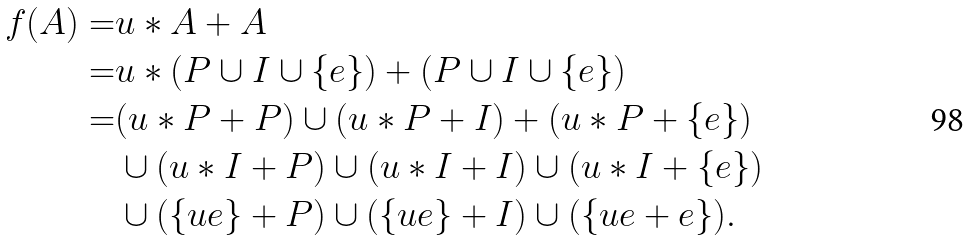Convert formula to latex. <formula><loc_0><loc_0><loc_500><loc_500>f ( A ) = & u \ast A + A \\ = & u \ast ( P \cup I \cup \{ e \} ) + ( P \cup I \cup \{ e \} ) \\ = & ( u \ast P + P ) \cup ( u \ast P + I ) + ( u \ast P + \{ e \} ) \\ & \cup ( u \ast I + P ) \cup ( u \ast I + I ) \cup ( u \ast I + \{ e \} ) \\ & \cup ( \{ u e \} + P ) \cup ( \{ u e \} + I ) \cup ( \{ u e + e \} ) .</formula> 